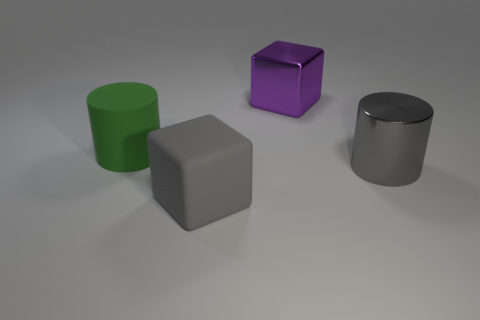The shiny object in front of the large matte object that is behind the metallic thing in front of the large green object is what shape?
Your answer should be very brief. Cylinder. What is the color of the other big thing that is the same shape as the gray rubber object?
Offer a terse response. Purple. What size is the object that is on the right side of the gray matte block and in front of the shiny cube?
Provide a short and direct response. Large. How many big cylinders are left of the block in front of the object that is behind the matte cylinder?
Keep it short and to the point. 1. How many big things are gray things or yellow shiny cylinders?
Give a very brief answer. 2. Is the material of the big cylinder that is behind the gray shiny thing the same as the big purple block?
Offer a terse response. No. There is a large gray object that is to the right of the purple metal object that is behind the big gray thing that is on the left side of the purple metallic object; what is it made of?
Give a very brief answer. Metal. What number of shiny things are green cylinders or blocks?
Ensure brevity in your answer.  1. Are there any gray rubber cylinders?
Ensure brevity in your answer.  No. What color is the cube that is behind the big cylinder to the left of the gray metallic cylinder?
Provide a succinct answer. Purple. 